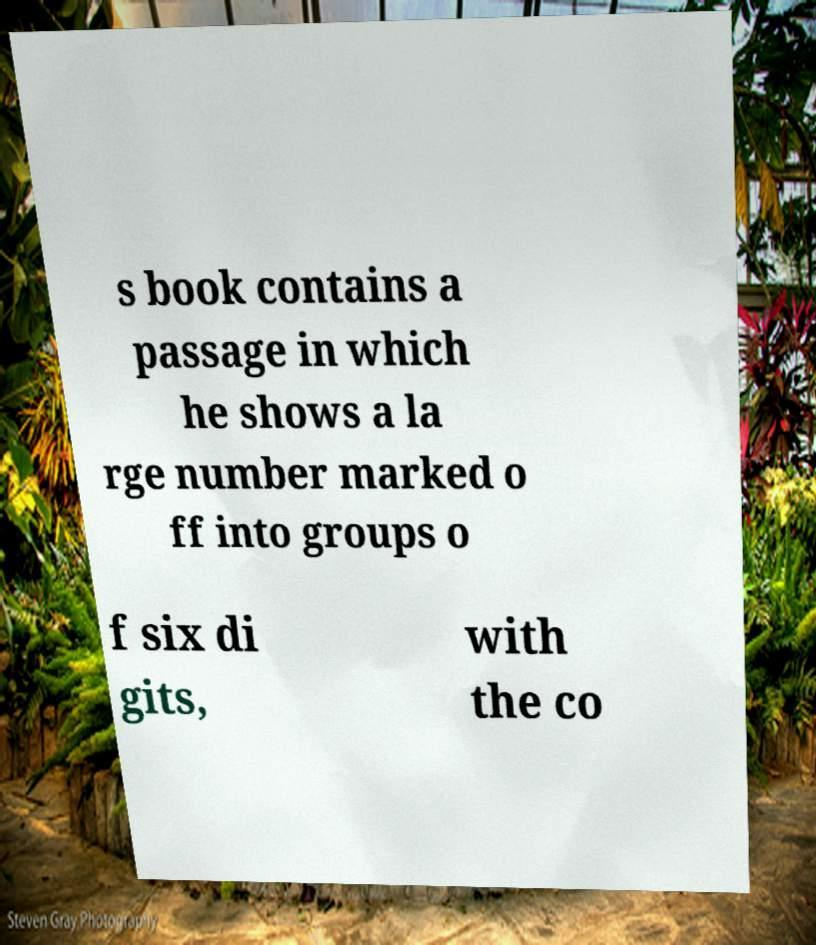Could you extract and type out the text from this image? s book contains a passage in which he shows a la rge number marked o ff into groups o f six di gits, with the co 